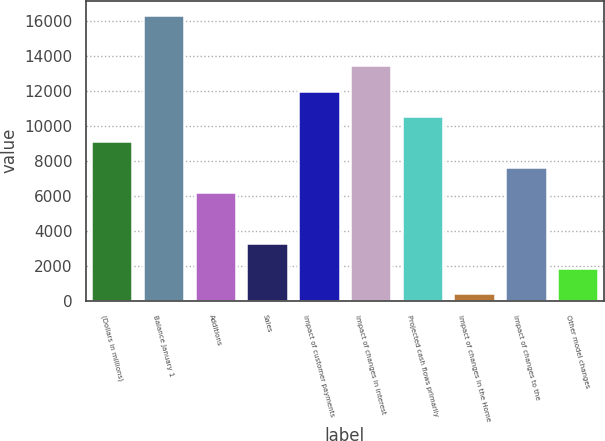Convert chart. <chart><loc_0><loc_0><loc_500><loc_500><bar_chart><fcel>(Dollars in millions)<fcel>Balance January 1<fcel>Additions<fcel>Sales<fcel>Impact of customer payments<fcel>Impact of changes in interest<fcel>Projected cash flows primarily<fcel>Impact of changes in the Home<fcel>Impact of changes to the<fcel>Other model changes<nl><fcel>9111.2<fcel>16347.2<fcel>6216.8<fcel>3322.4<fcel>12005.6<fcel>13452.8<fcel>10558.4<fcel>428<fcel>7664<fcel>1875.2<nl></chart> 